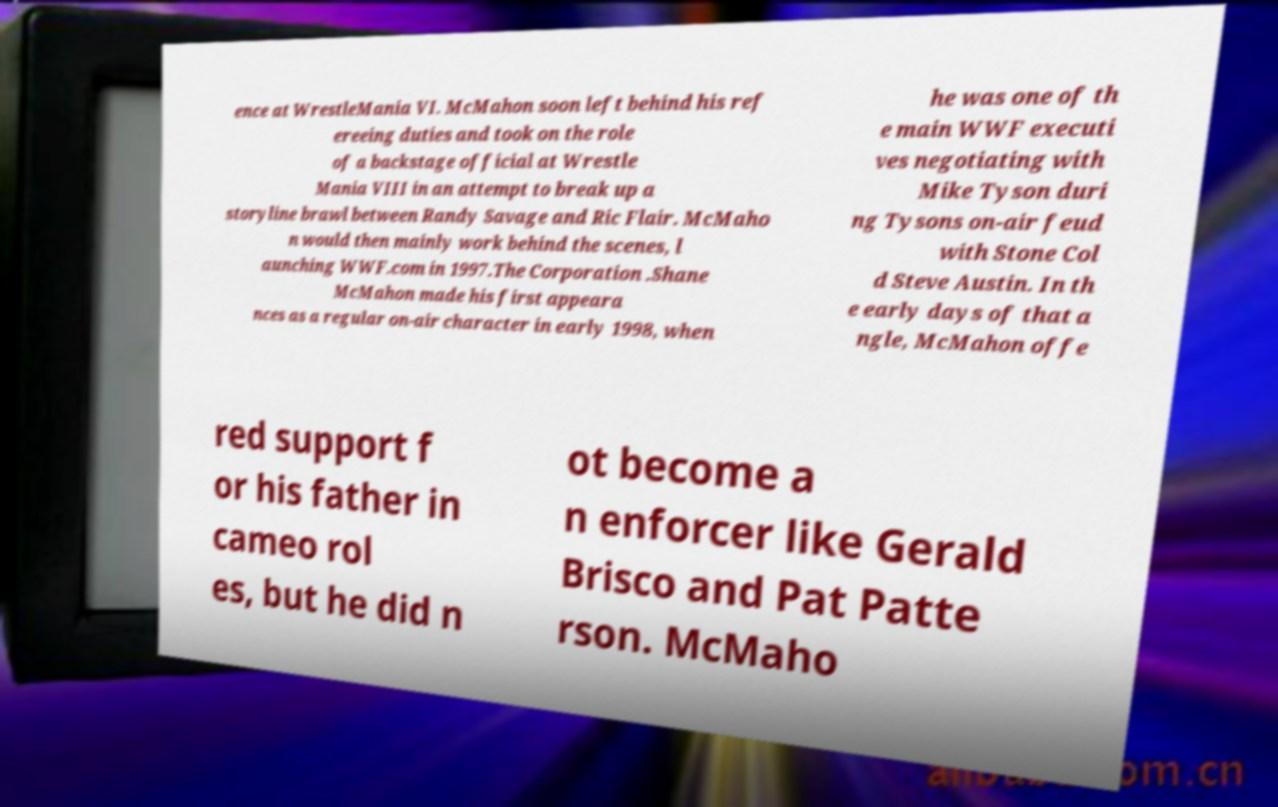For documentation purposes, I need the text within this image transcribed. Could you provide that? ence at WrestleMania VI. McMahon soon left behind his ref ereeing duties and took on the role of a backstage official at Wrestle Mania VIII in an attempt to break up a storyline brawl between Randy Savage and Ric Flair. McMaho n would then mainly work behind the scenes, l aunching WWF.com in 1997.The Corporation .Shane McMahon made his first appeara nces as a regular on-air character in early 1998, when he was one of th e main WWF executi ves negotiating with Mike Tyson duri ng Tysons on-air feud with Stone Col d Steve Austin. In th e early days of that a ngle, McMahon offe red support f or his father in cameo rol es, but he did n ot become a n enforcer like Gerald Brisco and Pat Patte rson. McMaho 